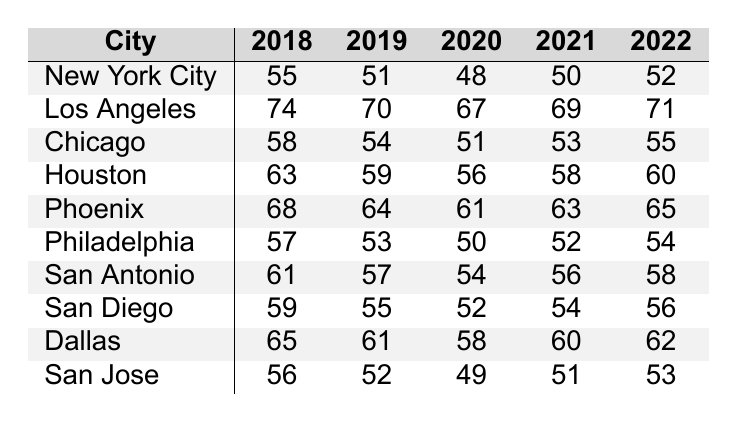What was the air quality index in Los Angeles in 2020? The table shows that the air quality index for Los Angeles is 67 in the year 2020.
Answer: 67 Which city had the highest air quality index on average over the years? To find the city with the highest average air quality index, I calculate the average for each city. For Los Angeles, it's (74+70+67+69+71)/5 = 662/5 = 66.4; for New York City, it's (55+51+48+50+52)/5 = 51.2; for Chicago, it’s 53; and similarly for others. The highest average is 66.4 for Los Angeles.
Answer: Los Angeles Did San Jose have a better air quality index than Chicago in 2021? The table shows that San Jose's air quality index was 51 and Chicago's was 53 in 2021. Since 51 is less than 53, San Jose did not have better air quality compared to Chicago.
Answer: No What is the change in air quality index for Houston from 2018 to 2022? For Houston, the air quality index in 2018 was 63 and in 2022 it was 60. The change is calculated as 60 - 63 = -3, indicating a decrease of 3.
Answer: Decreased by 3 Which city showed the biggest improvement in air quality from 2018 to 2022? I calculate the change for each city: New York City (55 to 52 = -3), Los Angeles (74 to 71 = -3), etc. The minimum change indicates no improvement; thus, all cities showed less favorable air quality at the end. San Antonio improved from 61 to 58, which is a lesser decline than most.
Answer: No city improved; all declined What is the average air quality index for Philadelphia over the five years? The air quality indexes for Philadelphia over the five years are 57, 53, 50, 52, and 54. Summing these gives 57 + 53 + 50 + 52 + 54 = 266. Dividing by 5 gives 266/5 = 53.2.
Answer: 53.2 In which year did San Diego have the highest air quality index? Looking at the values, the air quality index for San Diego in different years is 59, 55, 52, 54, and 56. The highest value is 59 in 2018.
Answer: 2018 Is the average air quality index for Dallas higher than 60? The values for Dallas are 65, 61, 58, 60, and 62. The total is 306, and dividing by 5 gives 306/5 = 61.2, which is greater than 60.
Answer: Yes What is the year-on-year trend for Phoenix's air quality index from 2018 to 2022? The air quality indexes for Phoenix are 68, 64, 61, 63, and 65. The trend shows a decrease from 2018 to 2020, followed by small increases in 2021 and 2022, indicating a fluctuating pattern but overall, a slight decrease from the starting year.
Answer: Decrease followed by slight increase 